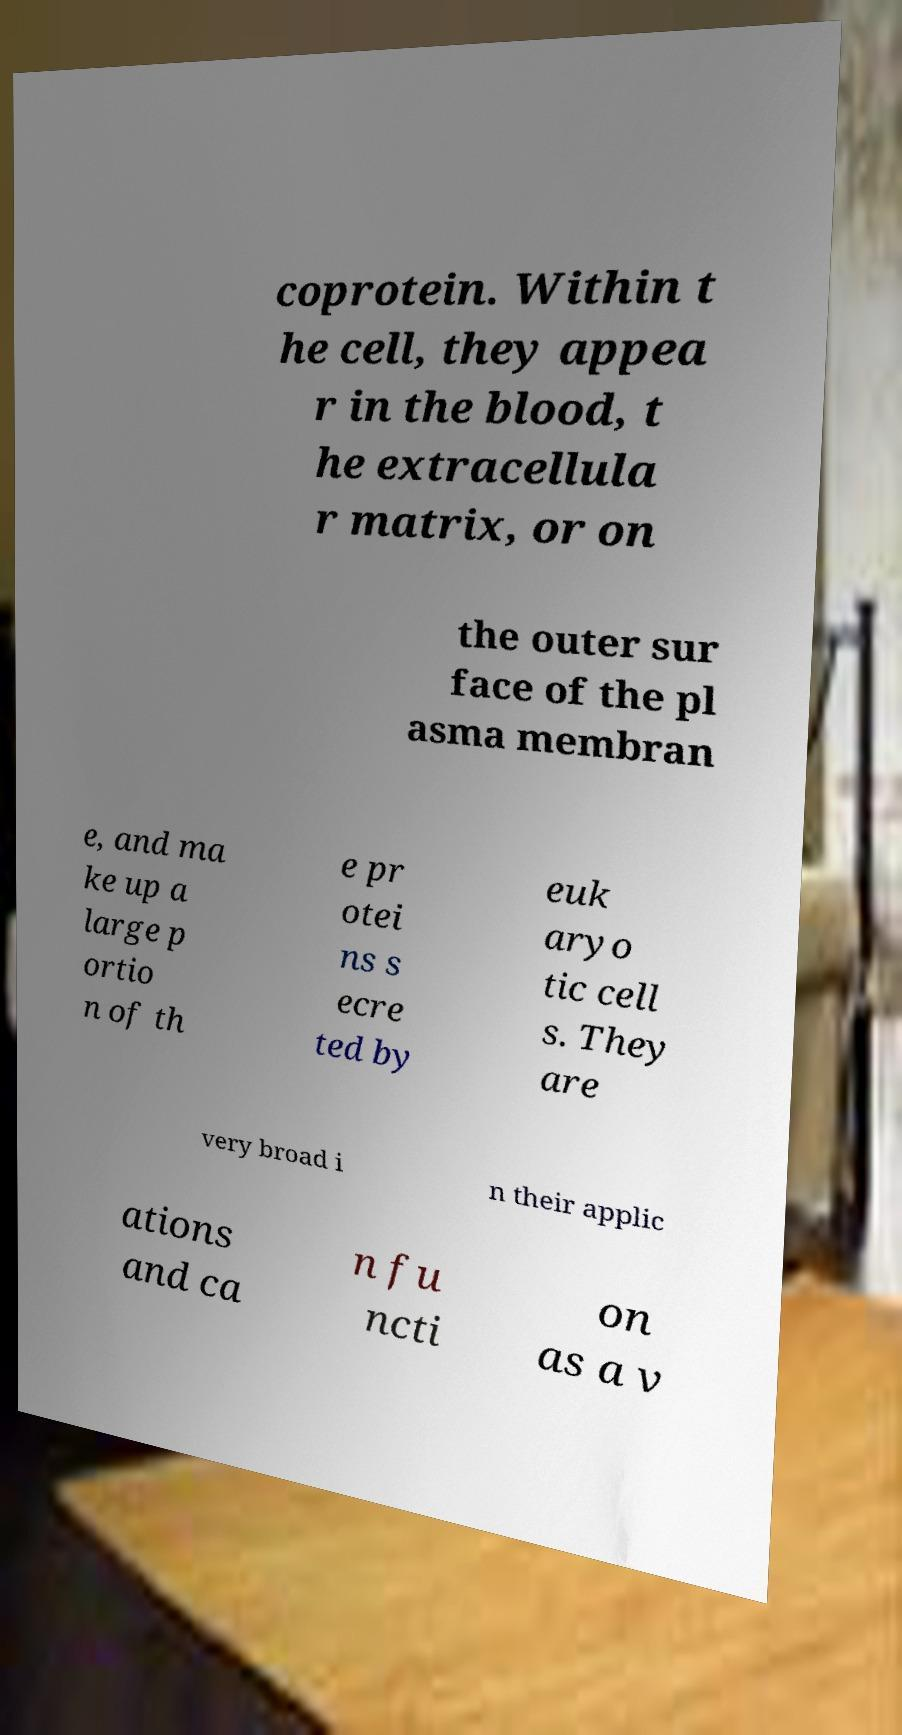Please identify and transcribe the text found in this image. coprotein. Within t he cell, they appea r in the blood, t he extracellula r matrix, or on the outer sur face of the pl asma membran e, and ma ke up a large p ortio n of th e pr otei ns s ecre ted by euk aryo tic cell s. They are very broad i n their applic ations and ca n fu ncti on as a v 